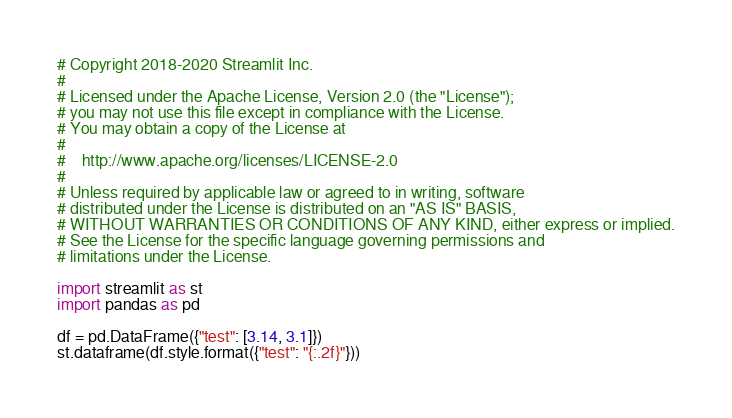<code> <loc_0><loc_0><loc_500><loc_500><_Python_># Copyright 2018-2020 Streamlit Inc.
#
# Licensed under the Apache License, Version 2.0 (the "License");
# you may not use this file except in compliance with the License.
# You may obtain a copy of the License at
#
#    http://www.apache.org/licenses/LICENSE-2.0
#
# Unless required by applicable law or agreed to in writing, software
# distributed under the License is distributed on an "AS IS" BASIS,
# WITHOUT WARRANTIES OR CONDITIONS OF ANY KIND, either express or implied.
# See the License for the specific language governing permissions and
# limitations under the License.

import streamlit as st
import pandas as pd

df = pd.DataFrame({"test": [3.14, 3.1]})
st.dataframe(df.style.format({"test": "{:.2f}"}))
</code> 